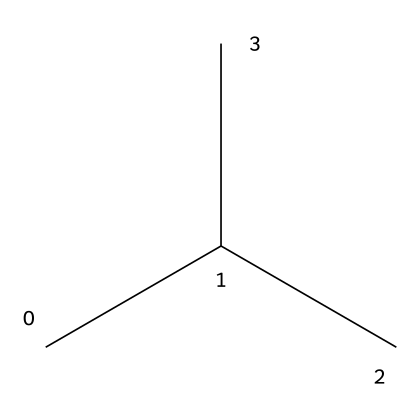What is the number of carbon atoms in the structure? By examining the SMILES representation, "CC(C)C", we can see that there are four distinct carbon atoms represented by the letters 'C'. Each 'C' indicates a carbon atom, and the grouping shows branching, indicating a total of four carbon atoms.
Answer: four What is the type of bonding in this chemical structure? The chemical structure indicated by "CC(C)C" demonstrates single bonds between the carbon atoms, as indicated by the linear nature of the SMILES notation without any double or triple bond indicators. This is characteristic of aliphatic hydrocarbons, suggesting only single bonding.
Answer: single What is the molecular formula for this compound? The SMILES translates to a compound with four carbon atoms and ten hydrogen atoms. Thus, the empirical formula can be derived by counting each atom represented, which results in the formula C4H10 for this structure.
Answer: C4H10 Is this chemical a saturated or unsaturated compound? The structure "CC(C)C" has only single bonds between its carbon atoms, indicating that it is a saturated hydrocarbon. Saturated compounds contain the maximum number of hydrogen atoms bonded to the carbon skeleton, without any double or triple bonds.
Answer: saturated What type of refrigerant does this chemical structure represent? This chemical, represented by "CC(C)C", resembles isobutane, a common refrigerant often used in portable cooling systems. It has environmentally friendly properties, thus making it suitable for disaster relief applications in terms of safety and minimal environmental impact.
Answer: isobutane What is the impact of this refrigerant on the ozone layer? Isobutane, as indicated by the structure "CC(C)C", is categorized as a refrigerant that has a low potential for ozone depletion. Unlike some traditional refrigerants, it does not contain chlorine, which is harmful to the ozone layer. Therefore, it has a minimal ozone-depleting potential compared to other common refrigerants.
Answer: low What is the significance of the branched structure in this refrigerant? The branched structure indicated in "CC(C)C" allows the refrigerant to have lower boiling points and better thermodynamic properties for efficient cooling. Branched alkanes tend to have improved thermal stability and reduced flammability, making them safer and more effective as refrigerants in portable cooling systems.
Answer: efficient cooling 